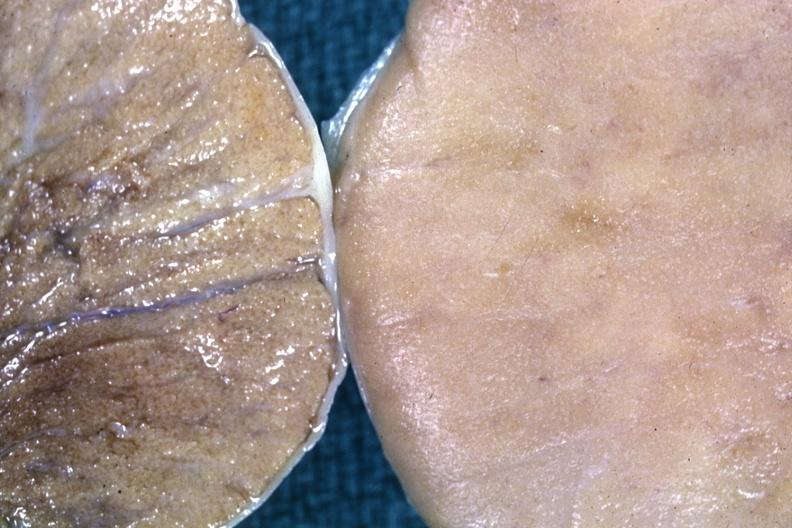s testicle present?
Answer the question using a single word or phrase. Yes 